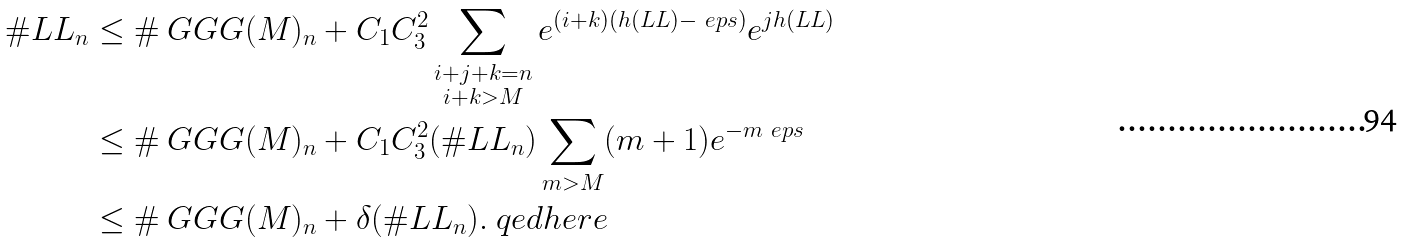<formula> <loc_0><loc_0><loc_500><loc_500>\# \L L L _ { n } & \leq \# \ G G G ( M ) _ { n } + C _ { 1 } C _ { 3 } ^ { 2 } \sum _ { \substack { i + j + k = n \\ i + k > M } } e ^ { ( i + k ) ( h ( \L L L ) - \ e p s ) } e ^ { j h ( \L L L ) } \\ & \leq \# \ G G G ( M ) _ { n } + C _ { 1 } C _ { 3 } ^ { 2 } ( \# \L L L _ { n } ) \sum _ { m > M } ( m + 1 ) e ^ { - m \ e p s } \\ & \leq \# \ G G G ( M ) _ { n } + \delta ( \# \L L L _ { n } ) . \ q e d h e r e</formula> 